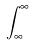<formula> <loc_0><loc_0><loc_500><loc_500>\int _ { \infty } ^ { \infty }</formula> 